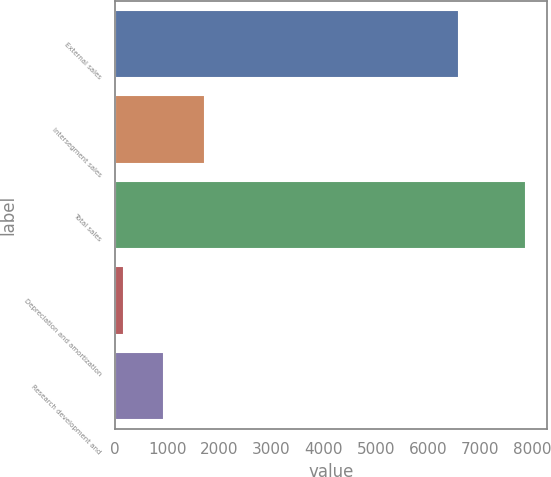<chart> <loc_0><loc_0><loc_500><loc_500><bar_chart><fcel>External sales<fcel>Intersegment sales<fcel>Total sales<fcel>Depreciation and amortization<fcel>Research development and<nl><fcel>6594<fcel>1714.4<fcel>7888<fcel>171<fcel>942.7<nl></chart> 